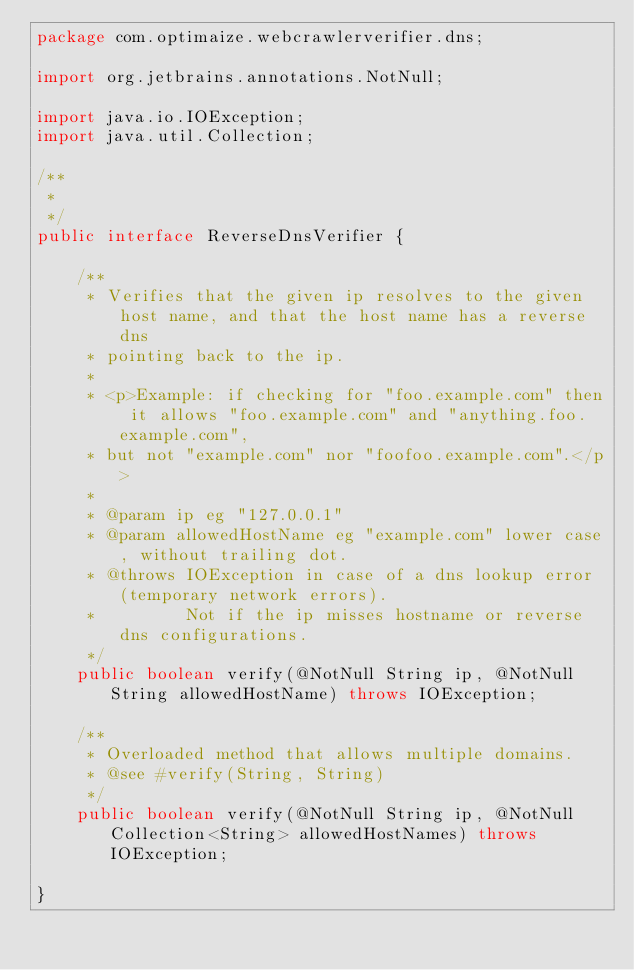Convert code to text. <code><loc_0><loc_0><loc_500><loc_500><_Java_>package com.optimaize.webcrawlerverifier.dns;

import org.jetbrains.annotations.NotNull;

import java.io.IOException;
import java.util.Collection;

/**
 *
 */
public interface ReverseDnsVerifier {

    /**
     * Verifies that the given ip resolves to the given host name, and that the host name has a reverse dns
     * pointing back to the ip.
     *
     * <p>Example: if checking for "foo.example.com" then it allows "foo.example.com" and "anything.foo.example.com",
     * but not "example.com" nor "foofoo.example.com".</p>
     *
     * @param ip eg "127.0.0.1"
     * @param allowedHostName eg "example.com" lower case, without trailing dot.
     * @throws IOException in case of a dns lookup error (temporary network errors).
     *         Not if the ip misses hostname or reverse dns configurations.
     */
    public boolean verify(@NotNull String ip, @NotNull String allowedHostName) throws IOException;

    /**
     * Overloaded method that allows multiple domains.
     * @see #verify(String, String)
     */
    public boolean verify(@NotNull String ip, @NotNull Collection<String> allowedHostNames) throws IOException;

}
</code> 